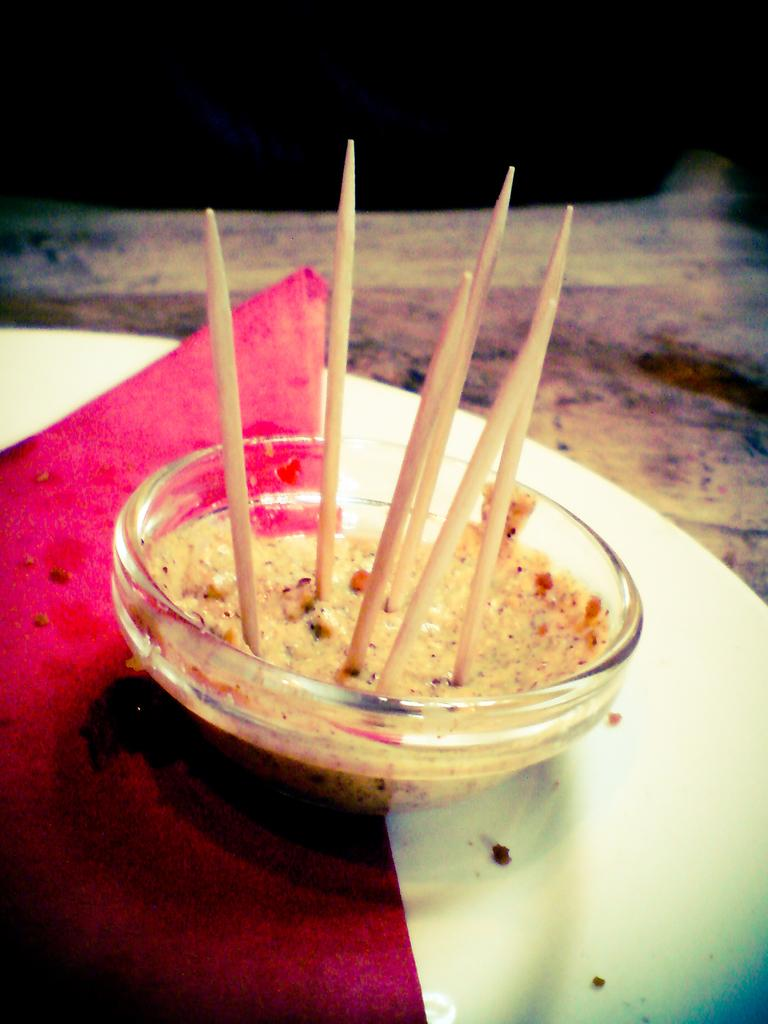What is in the bowl that is visible in the image? Toothpicks are present in the bowl. What is on the plate in the image? A napkin is on the plate. Where are the plate and napkin located? The plate and napkin are on a table. What might be used to hold or serve food in the image? The bowl and plate can be used to hold or serve food. What riddle is hidden in the minute details of the image? There is no riddle hidden in the image, as it only contains a bowl, toothpicks, a plate, a napkin, and a table. 